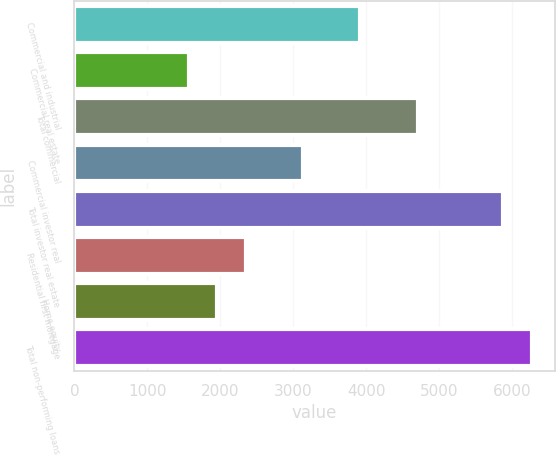<chart> <loc_0><loc_0><loc_500><loc_500><bar_chart><fcel>Commercial and industrial<fcel>Commercial real estate<fcel>Total commercial<fcel>Commercial investor real<fcel>Total investor real estate<fcel>Residential first mortgage<fcel>Home equity<fcel>Total non-performing loans<nl><fcel>3918<fcel>1568.4<fcel>4701.2<fcel>3134.8<fcel>5876<fcel>2351.6<fcel>1960<fcel>6267.6<nl></chart> 